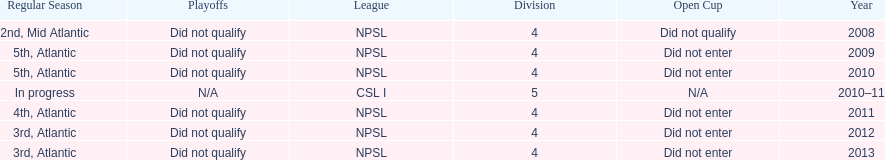Excluding npsl, what is another league that the ny men's soccer team has been a part of? CSL I. 